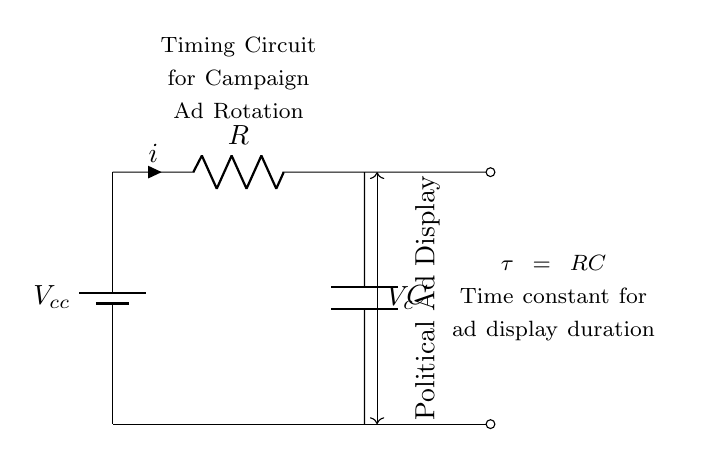What does the capacitor do in this circuit? The capacitor stores electrical energy and releases it over time, impacting the timing of the circuit for displaying advertisements.
Answer: Stores energy What is the function of the resistor in this circuit? The resistor limits the current flowing through the circuit, which in turn affects the time constant and charging time of the capacitor.
Answer: Limits current What is the time constant formula in this circuit? The time constant is given by the product of the resistor value and the capacitor value, denoted by tau equal to RC.
Answer: tau = RC What does the voltage across the capacitor represent? The voltage across the capacitor represents the stored energy in the capacitor as it charges during the circuit operation.
Answer: Stored energy What happens to the current when the capacitor is fully charged? When the capacitor is fully charged, the current flow effectively stops, as the voltage across the capacitor equals the supply voltage, causing the circuit to stabilize.
Answer: Current stops How does the circuit impact advertisement rotation time? The timing of advertisement rotation is determined by the time constant, which affects how long the display remains before switching to the next ad.
Answer: Determines rotation time 